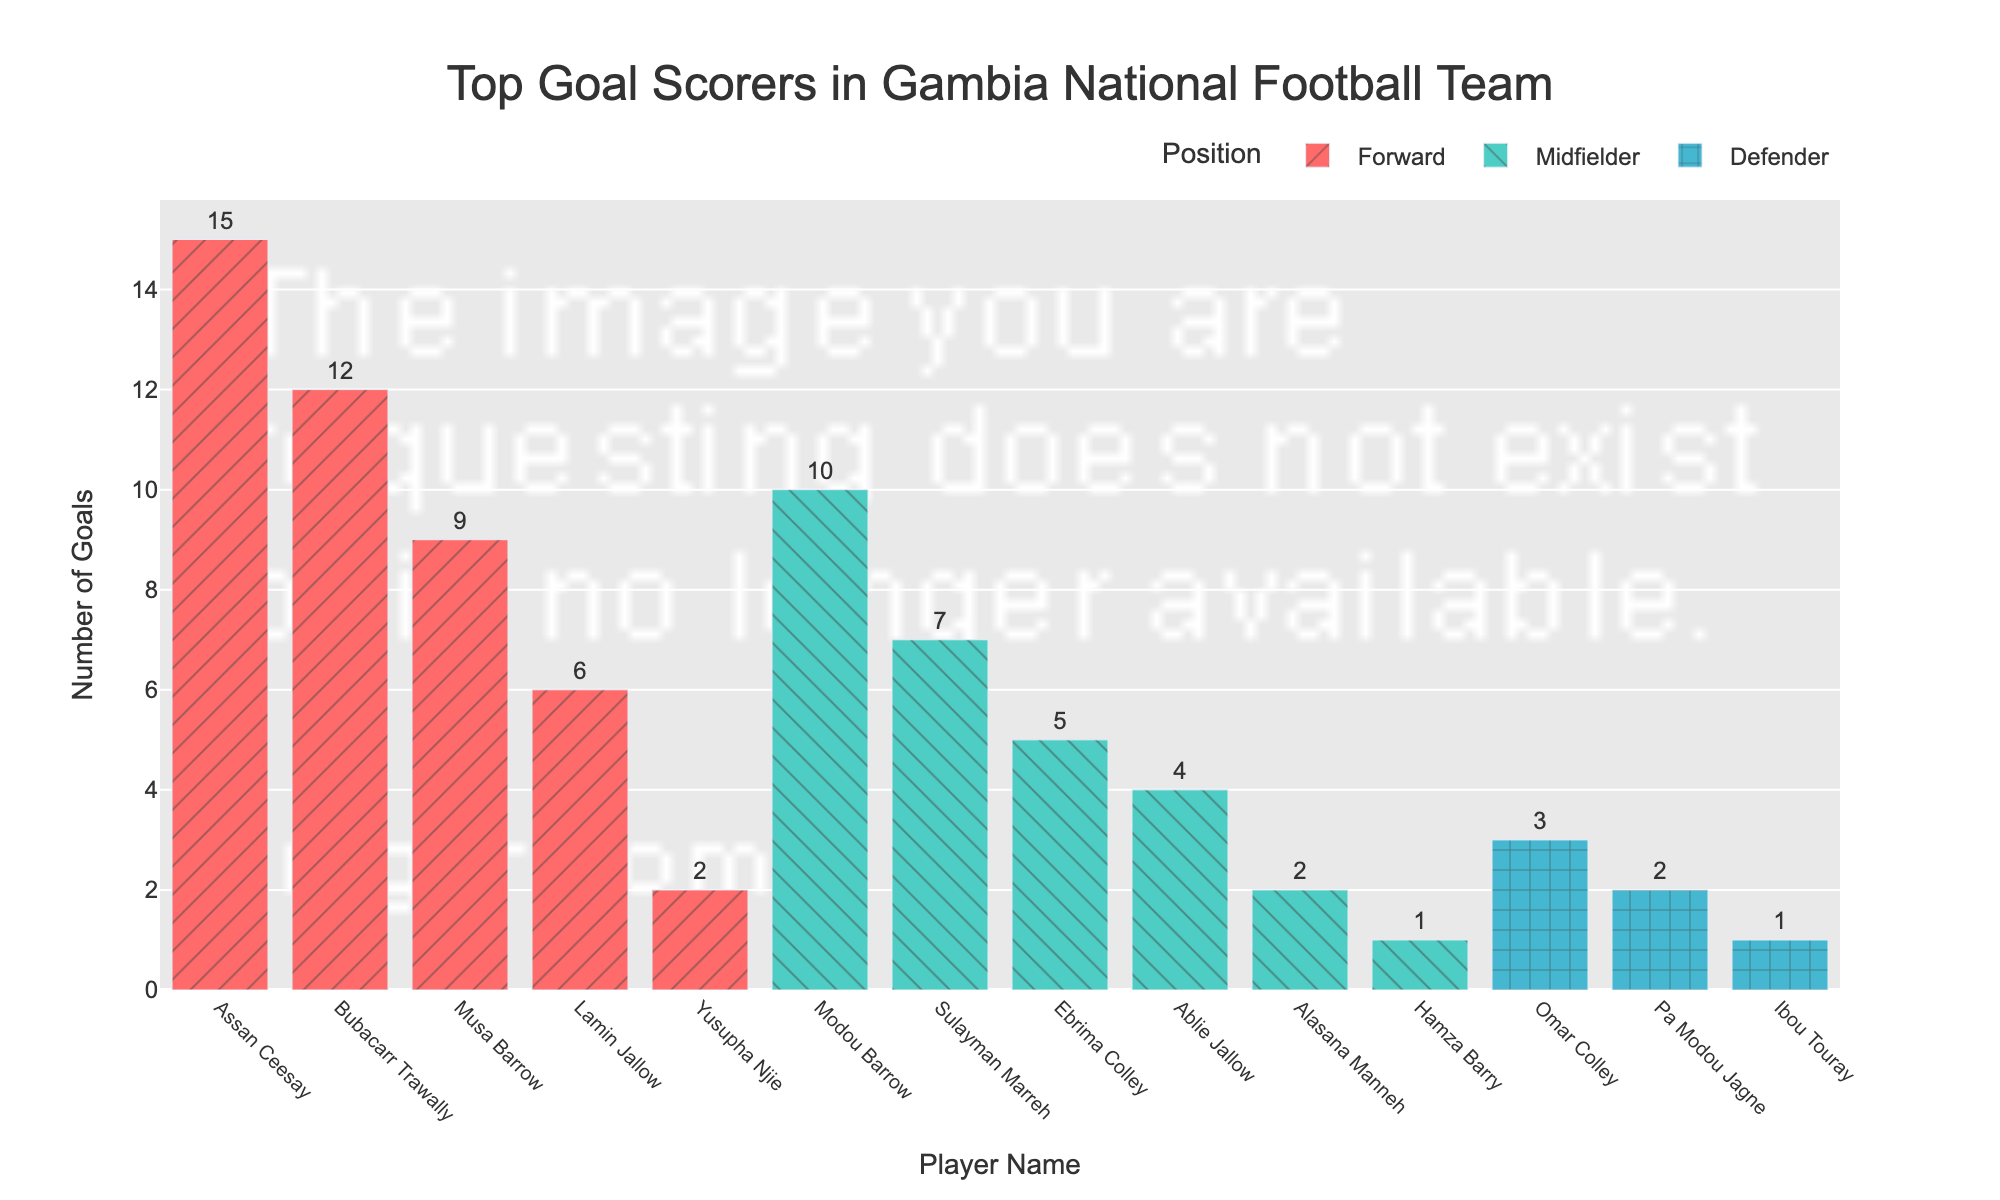what's the player with the highest number of goals? The player with the highest number of goals is the one with the tallest bar. By looking at the figure, Assan Ceesay has the tallest bar.
Answer: Assan Ceesay how many goals were scored by Midfielders in total? To find the total goals scored by Midfielders, sum the goals from all Midfielders: Modou Barrow (10) + Sulayman Marreh (7) + Ebrima Colley (5) + Ablie Jallow (4) + Alasana Manneh (2) + Hamza Barry (1). This totals \(10 + 7 + 5 + 4 + 2 + 1\).
Answer: 29 compare Assan Ceesay and Bubacarr Trawally, who has more goals and by how many? Assan Ceesay has 15 goals while Bubacarr Trawally has 12 goals. The difference is \(15 - 12\).
Answer: Assan Ceesay, 3 goals what's the ratio of goals between the highest-scoring Forward and the highest-scoring Midfielder? The highest-scoring Forward is Assan Ceesay with 15 goals. The highest-scoring Midfielder is Modou Barrow with 10 goals. The ratio of their goals is \(15 / 10\).
Answer: 1.5 which position has the second most number of top goal scorers? By counting the number of players in each position among top goal scorers, Forwards have 5 players, Midfielders have 6 players, and Defenders have 3 players. The second most common position is the Defender with 3 players.
Answer: Defender what's the combined goals of all the Defenders? Sum the goals from all Defenders: Omar Colley (3) + Pa Modou Jagne (2) + Ibou Touray (1). This totals \(3 + 2 + 1\).
Answer: 6 among the top three goal scorers, who is the only Midfielder? By inspecting the top three bar heights, Assan Ceesay and Bubacarr Trawally are Forwards, and Modou Barrow is the only Midfielder.
Answer: Modou Barrow how many more goals did Forwards score compared to Defenders? Sum the goals scored by Forwards (Assan Ceesay (15), Bubacarr Trawally (12), Musa Barrow (9), Lamin Jallow (6), and Yusupha Njie (2)) to get \(15 + 12 + 9 + 6 + 2 = 44\). Sum the goals scored by Defenders (Omar Colley (3), Pa Modou Jagne (2), Ibou Touray (1)) to get \(3 + 2 + 1 = 6\). The difference is \(44 - 6\).
Answer: 38 what's the average number of goals scored by Defenders? Sum the goals scored by all the Defenders and divide by the number of Defenders: \(3 + 2 + 1) / 3\).
Answer: 2 which players scored exactly 2 goals? By identifying the bars of height 2, the players Pa Modou Jagne, Alasana Manneh, and Yusupha Njie each scored 2 goals.
Answer: Pa Modou Jagne, Alasana Manneh, Yusupha Njie 